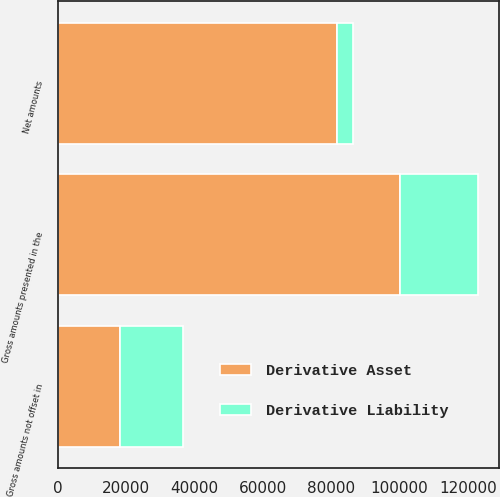Convert chart. <chart><loc_0><loc_0><loc_500><loc_500><stacked_bar_chart><ecel><fcel>Gross amounts presented in the<fcel>Gross amounts not offset in<fcel>Net amounts<nl><fcel>Derivative Liability<fcel>22970<fcel>18313<fcel>4657<nl><fcel>Derivative Asset<fcel>100038<fcel>18313<fcel>81725<nl></chart> 